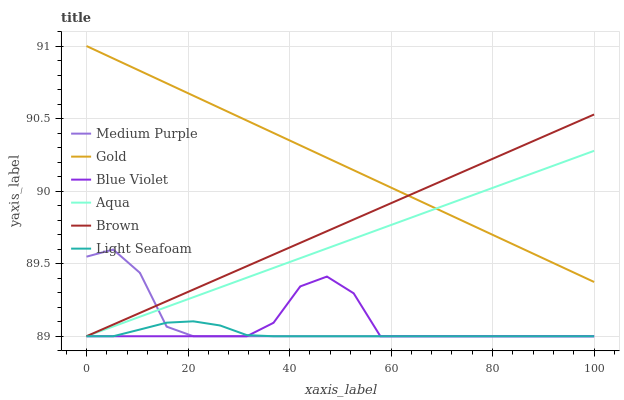Does Aqua have the minimum area under the curve?
Answer yes or no. No. Does Aqua have the maximum area under the curve?
Answer yes or no. No. Is Gold the smoothest?
Answer yes or no. No. Is Gold the roughest?
Answer yes or no. No. Does Gold have the lowest value?
Answer yes or no. No. Does Aqua have the highest value?
Answer yes or no. No. Is Light Seafoam less than Gold?
Answer yes or no. Yes. Is Gold greater than Medium Purple?
Answer yes or no. Yes. Does Light Seafoam intersect Gold?
Answer yes or no. No. 